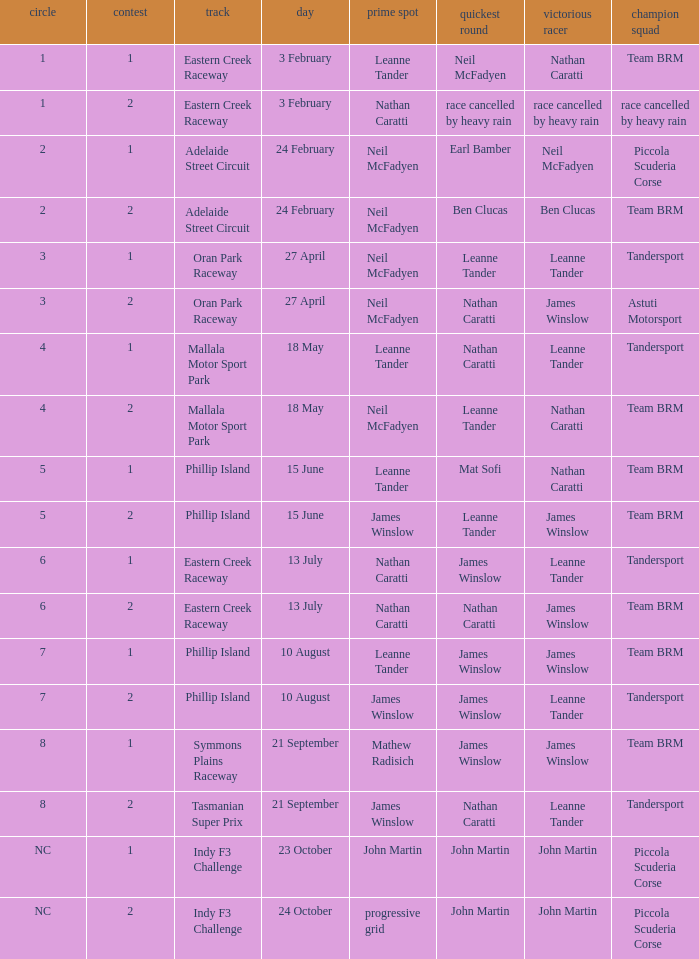Which race number in the Indy F3 Challenge circuit had John Martin in pole position? 1.0. 